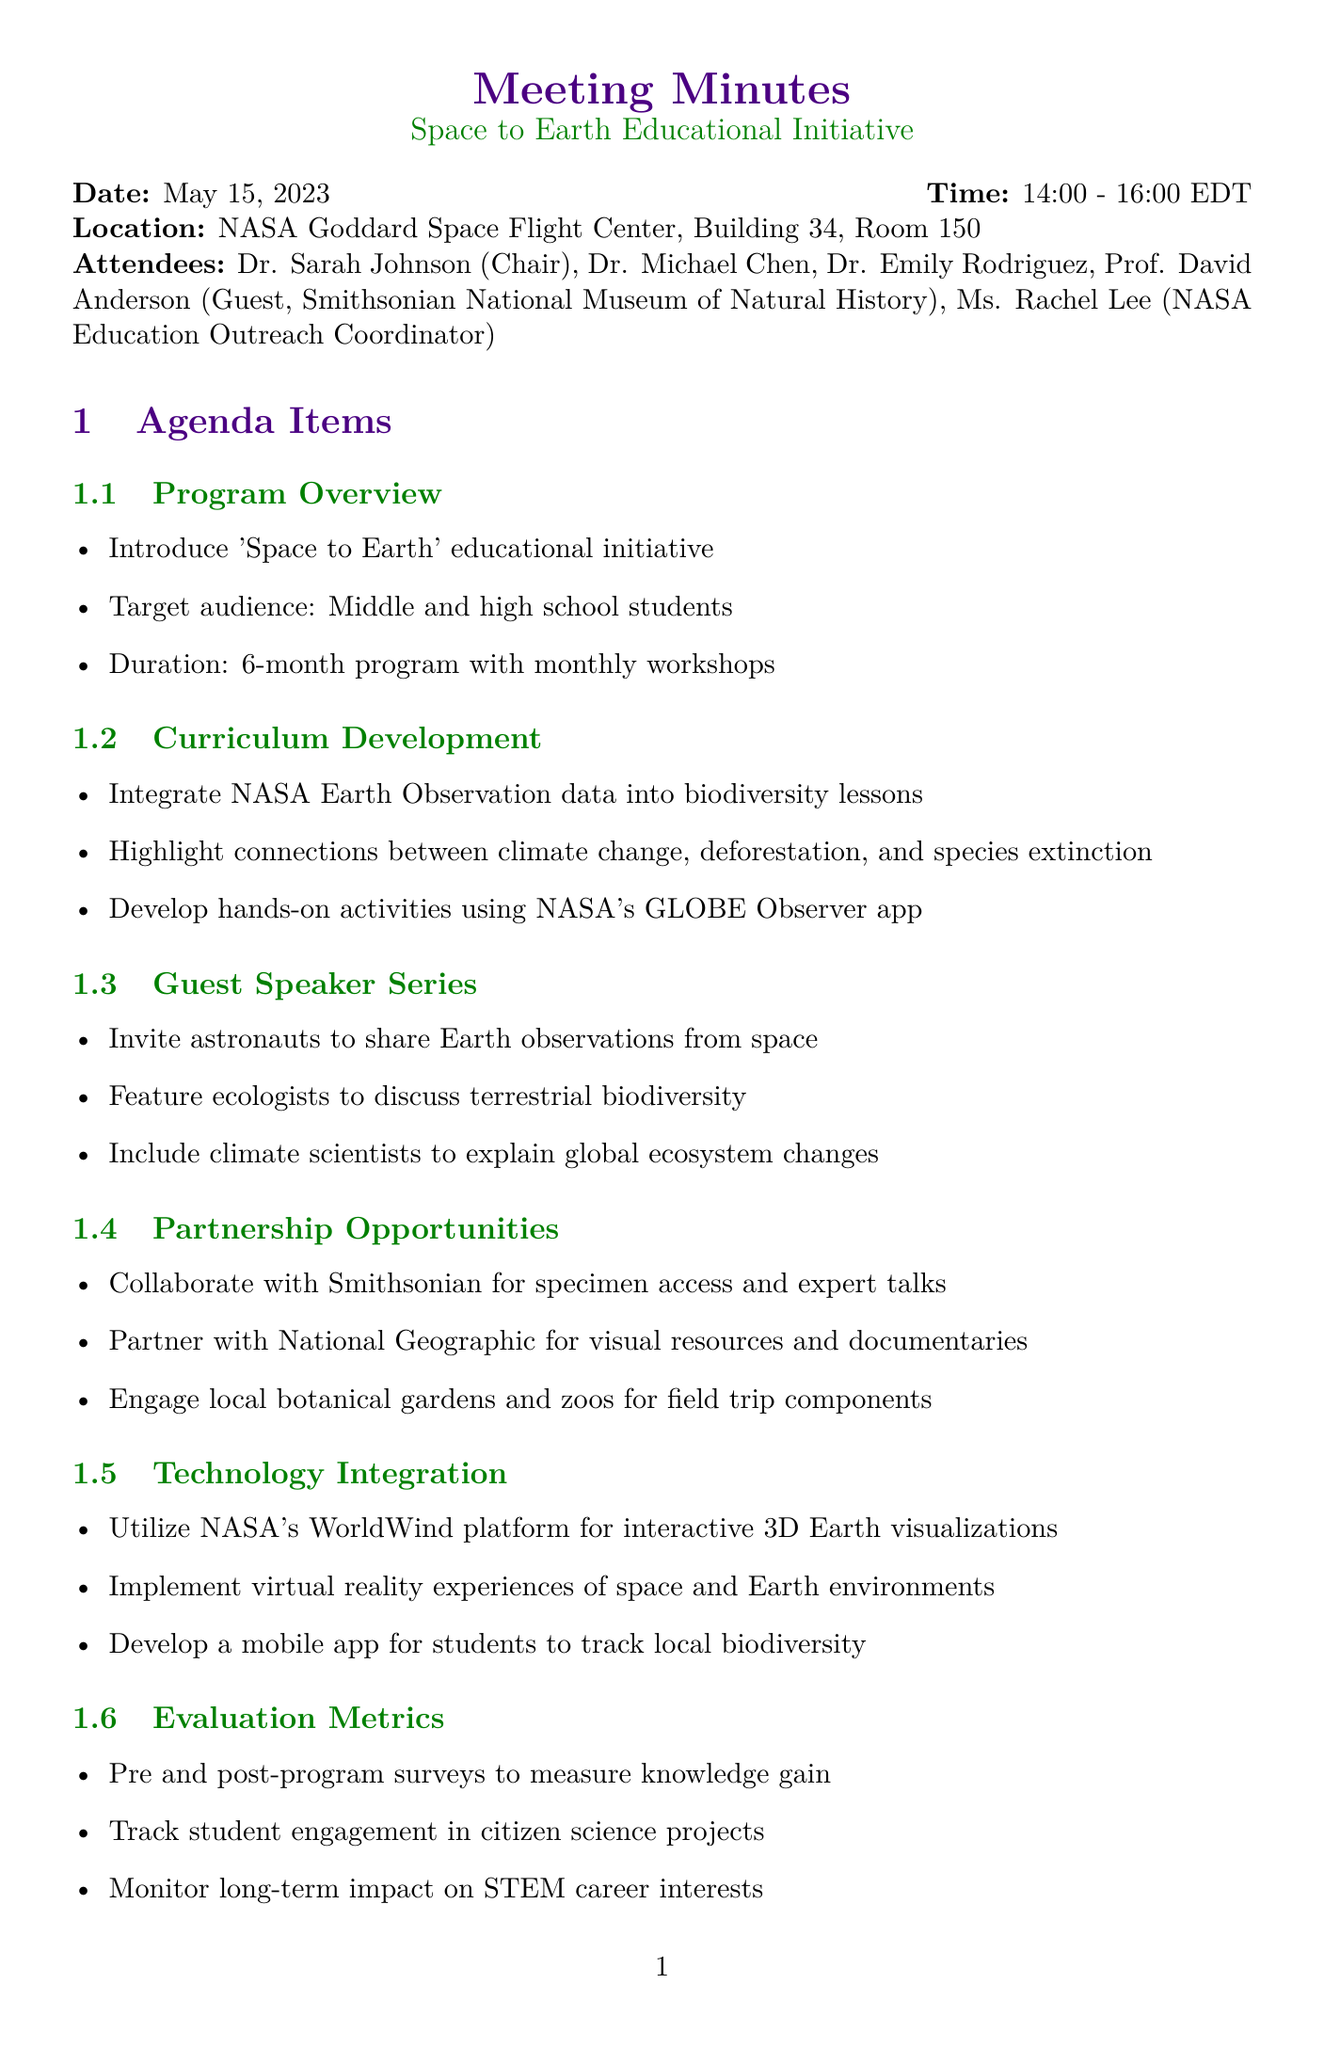What is the date of the meeting? The meeting is scheduled for May 15, 2023.
Answer: May 15, 2023 Who is the chair of the meeting? The chair of the meeting is Dr. Sarah Johnson.
Answer: Dr. Sarah Johnson What is the target audience for the program? The target audience is middle and high school students.
Answer: Middle and high school students How long is the program planned to last? The program is planned to last for 6 months with monthly workshops.
Answer: 6-month program Which platform will be utilized for interactive 3D Earth visualizations? The platform being utilized is NASA's WorldWind.
Answer: NASA's WorldWind What is one of the action items assigned to Ms. Lee? Ms. Lee is to contact potential guest speakers by May 30th.
Answer: Contact potential guest speakers by May 30th What type of experiences will be implemented to enhance technology integration? Virtual reality experiences of space and Earth environments will be implemented.
Answer: Virtual reality experiences When is the next meeting scheduled? The next meeting is scheduled for June 5, 2023.
Answer: June 5, 2023 Who is responsible for drafting the evaluation plan? Dr. Rodriguez is responsible for drafting the evaluation plan.
Answer: Dr. Rodriguez 